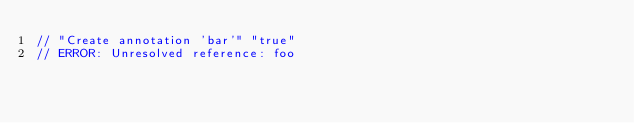<code> <loc_0><loc_0><loc_500><loc_500><_Kotlin_>// "Create annotation 'bar'" "true"
// ERROR: Unresolved reference: foo
</code> 